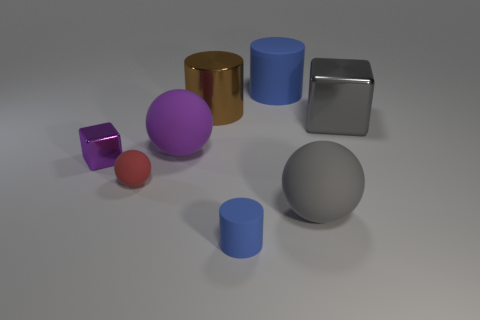Add 1 tiny purple metallic objects. How many objects exist? 9 Add 5 rubber things. How many rubber things exist? 10 Subtract all purple cubes. How many cubes are left? 1 Subtract all big matte cylinders. How many cylinders are left? 2 Subtract 0 green blocks. How many objects are left? 8 Subtract all balls. How many objects are left? 5 Subtract 2 cylinders. How many cylinders are left? 1 Subtract all green spheres. Subtract all yellow blocks. How many spheres are left? 3 Subtract all blue spheres. How many blue cubes are left? 0 Subtract all purple balls. Subtract all large blue matte things. How many objects are left? 6 